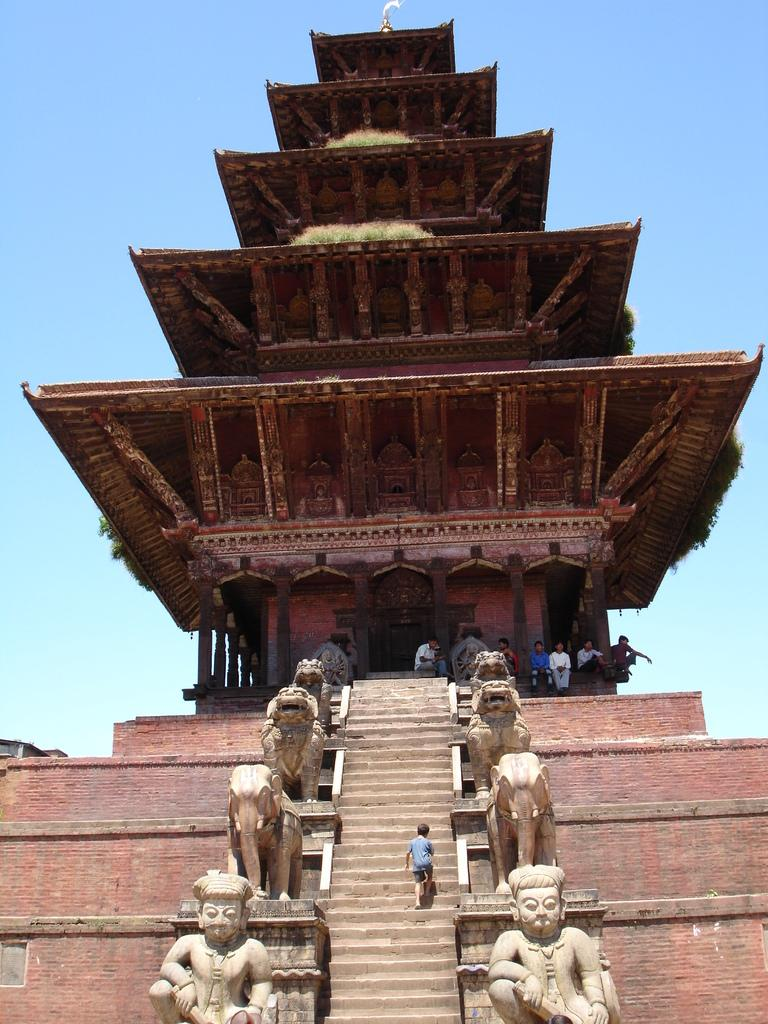What type of building is in the image? There is a temple in the image. What architectural features can be seen in the image? There are pillars in the image. What type of vegetation is present in the image? There are plants in the image. What type of artwork can be seen in the image? There are sculptures in the image. What type of structure is present in the image for climbing? There are stairs in the image. What type of barrier is present in the image? There is a wall in the image. Are there any people in the image? Yes, there are people in the image. What can be seen in the background of the image? The sky is visible in the background of the image. What type of bear can be seen working in the group in the image? There is no bear present in the image, nor is there any indication of work or a group. 